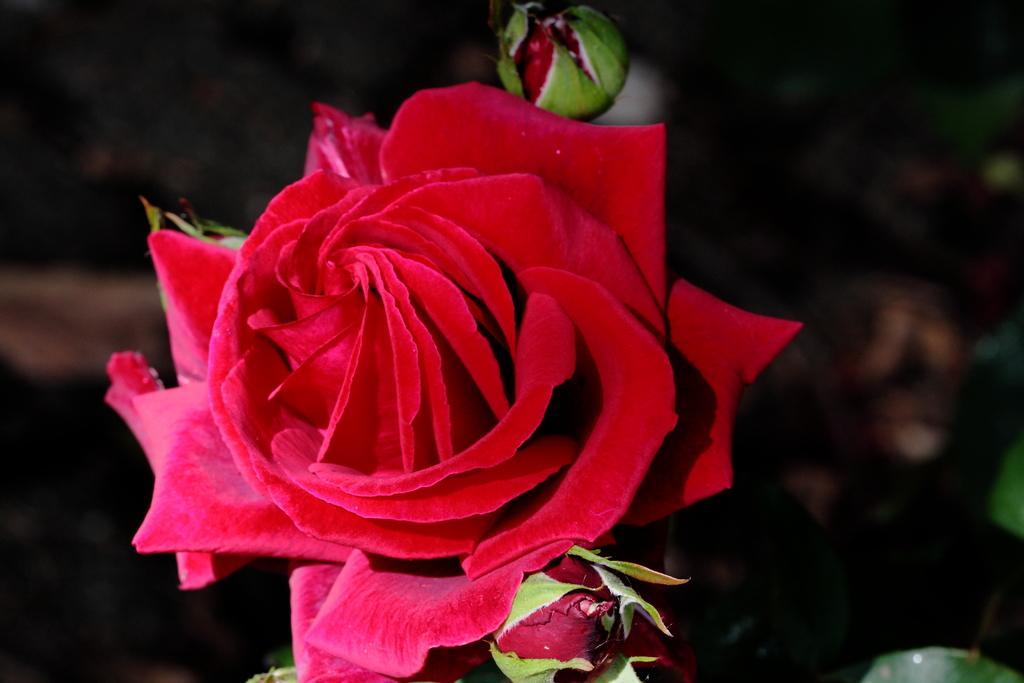Can you describe this image briefly? In the picture I can see a red color rose and buds and the background of the image is dark. 